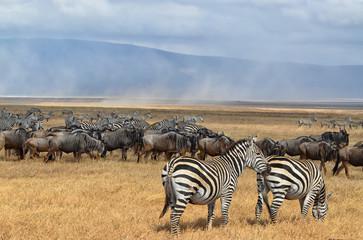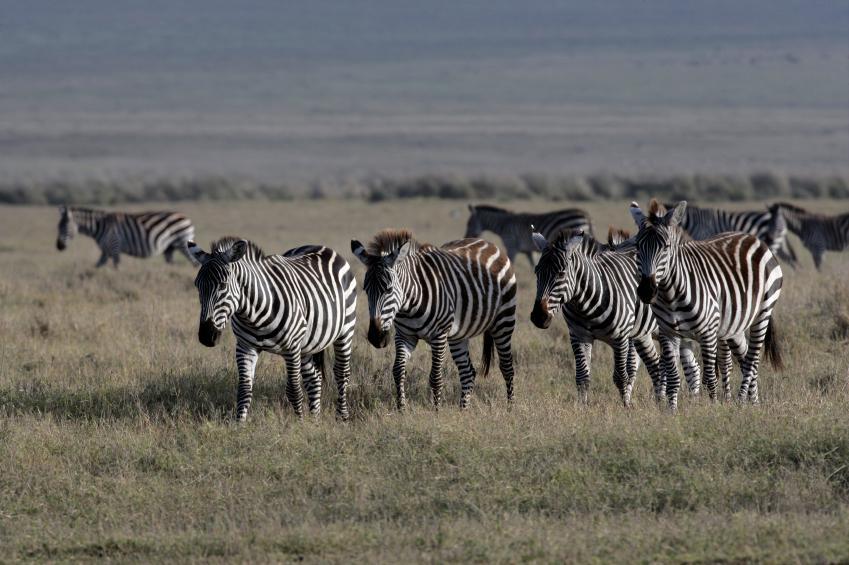The first image is the image on the left, the second image is the image on the right. Evaluate the accuracy of this statement regarding the images: "There are trees visible in both images.". Is it true? Answer yes or no. No. The first image is the image on the left, the second image is the image on the right. For the images displayed, is the sentence "One image contains multiple rear-facing zebra in the foreground, and all images show only dry ground with no non-zebra animal herds visible." factually correct? Answer yes or no. No. 